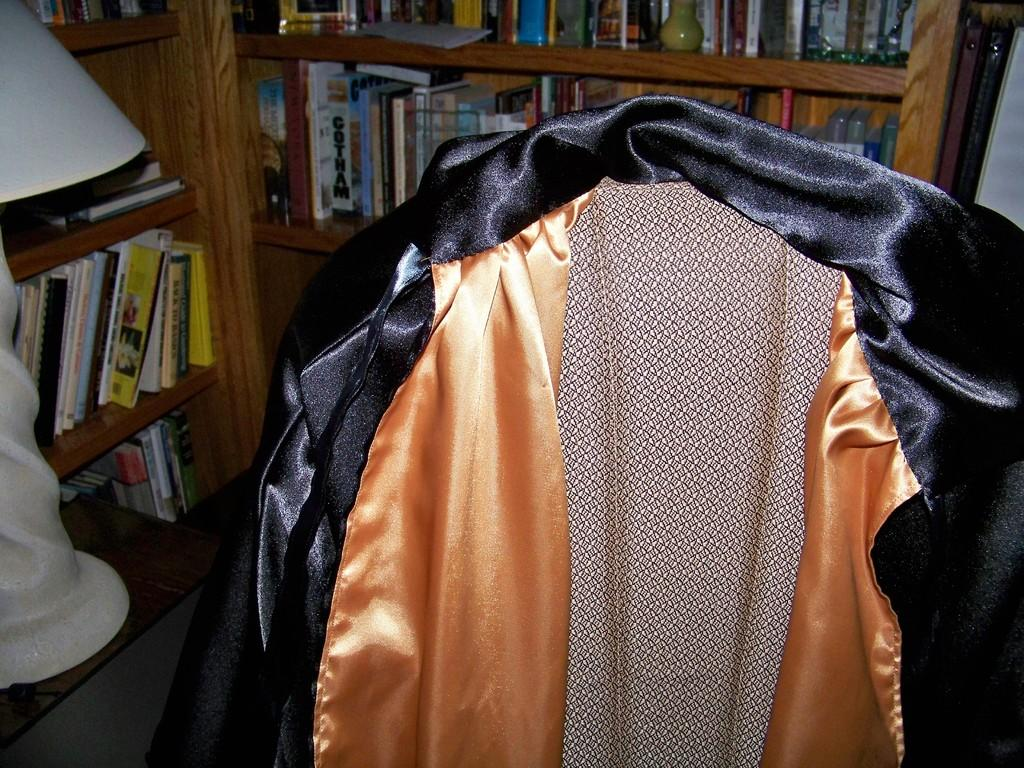What can be seen on the shelves in the image? There are many books in the shelves. What is the coat placed on? The coat is placed on an object. Where is the lamp located in the image? The lamp is at the left side of the image. How hot is the trip depicted in the image? There is no trip depicted in the image, and the concept of "hot" is not relevant to the objects shown. 